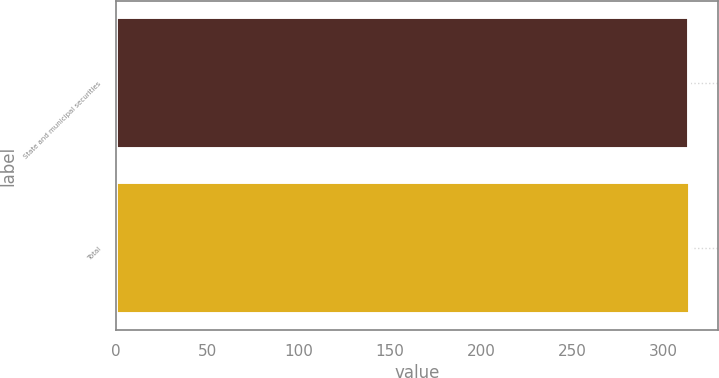Convert chart to OTSL. <chart><loc_0><loc_0><loc_500><loc_500><bar_chart><fcel>State and municipal securities<fcel>Total<nl><fcel>314<fcel>314.1<nl></chart> 